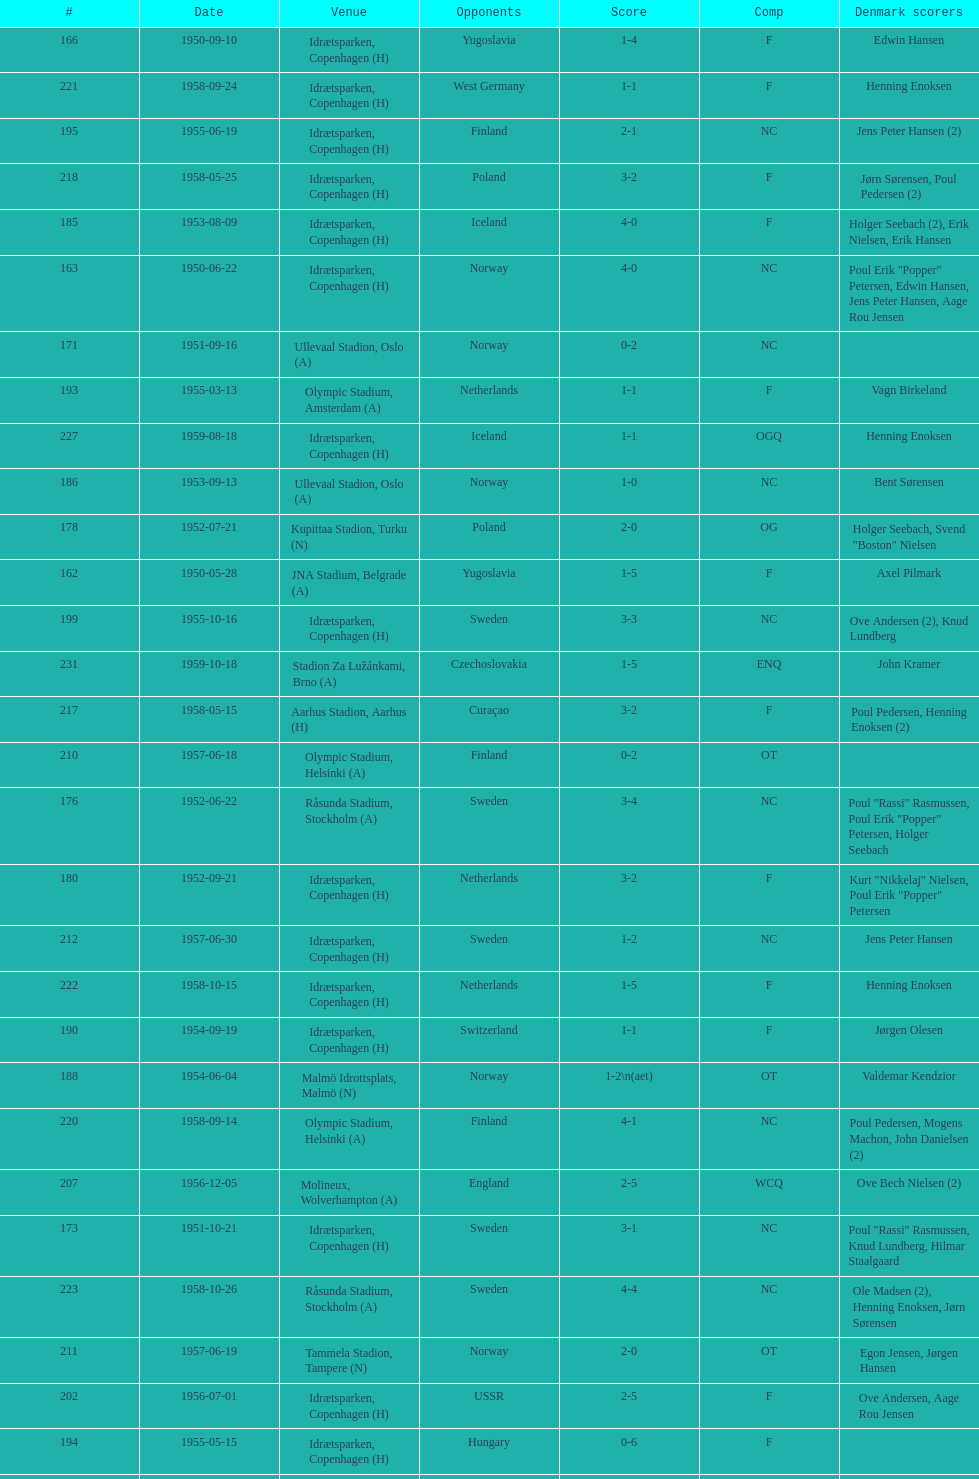What is the venue right below jna stadium, belgrade (a)? Idrætsparken, Copenhagen (H). 